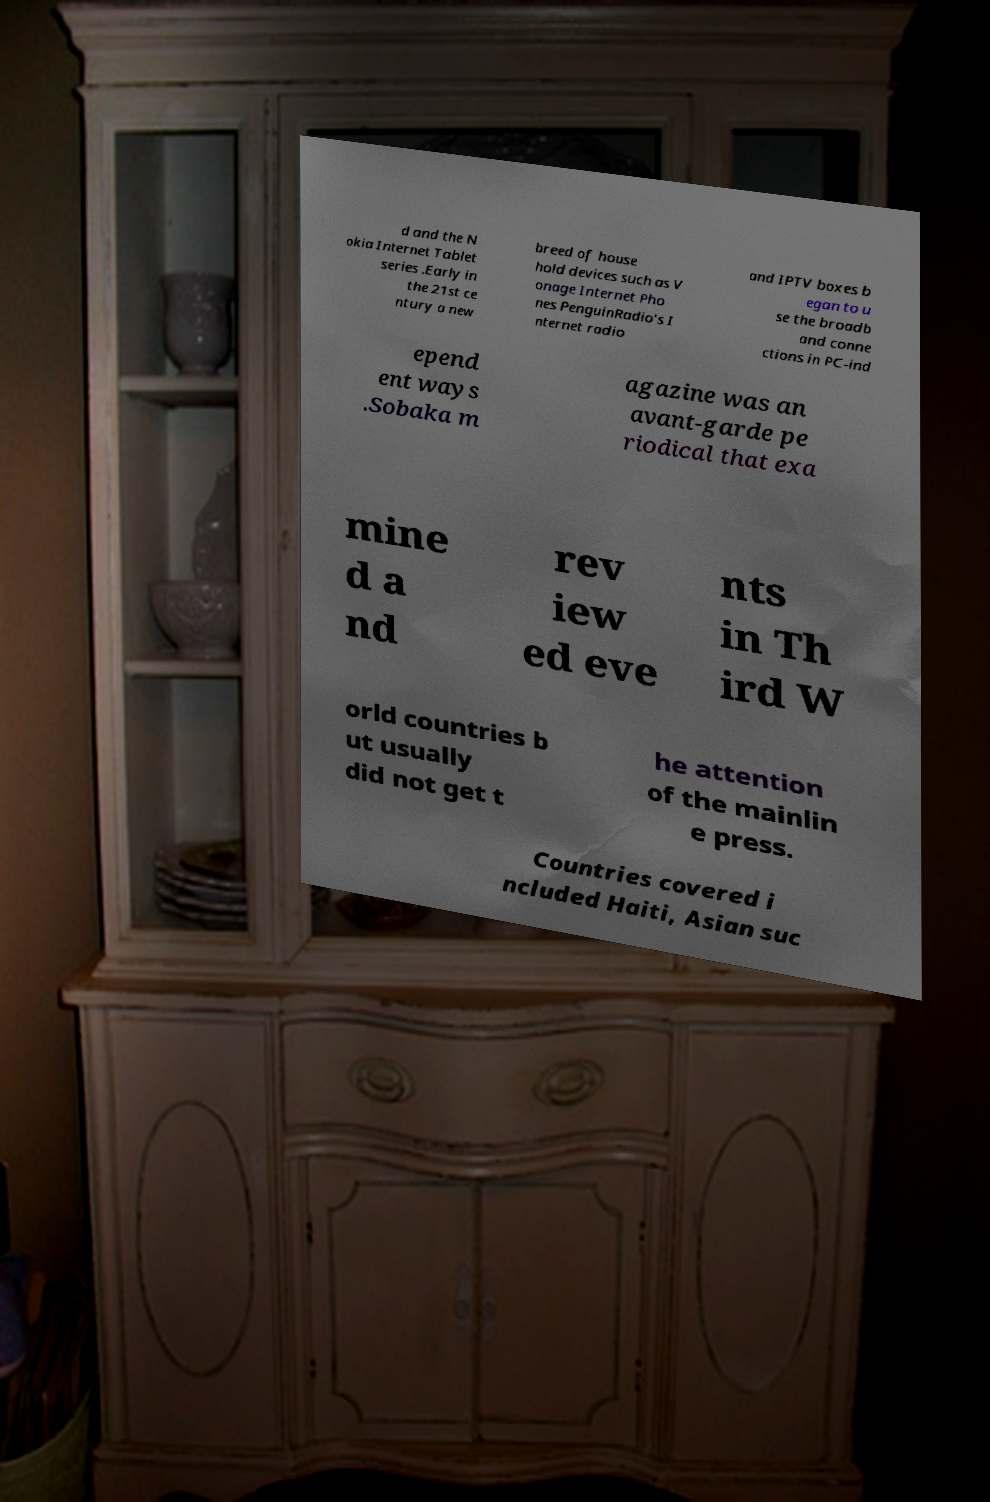I need the written content from this picture converted into text. Can you do that? d and the N okia Internet Tablet series .Early in the 21st ce ntury a new breed of house hold devices such as V onage Internet Pho nes PenguinRadio's I nternet radio and IPTV boxes b egan to u se the broadb and conne ctions in PC-ind epend ent ways .Sobaka m agazine was an avant-garde pe riodical that exa mine d a nd rev iew ed eve nts in Th ird W orld countries b ut usually did not get t he attention of the mainlin e press. Countries covered i ncluded Haiti, Asian suc 